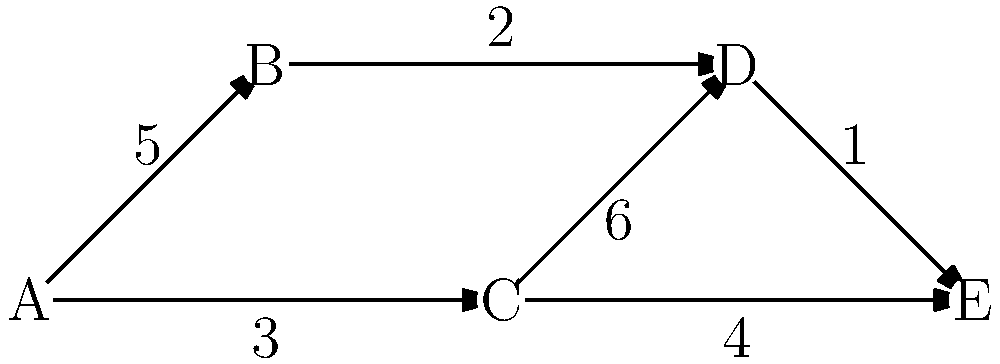In a coding competition, the graph represents the leaderboard progression. Vertices are checkpoints, and edges are challenges with associated point values. Starting from checkpoint A, what is the maximum total points a team can accumulate to reach checkpoint E? To find the maximum total points, we need to determine the path with the highest sum of edge weights from A to E. Let's analyze all possible paths:

1. Path A → B → D → E:
   $5 + 2 + 1 = 8$ points

2. Path A → C → D → E:
   $3 + 6 + 1 = 10$ points

3. Path A → C → E:
   $3 + 4 = 7$ points

To solve this systematically, we can use the concept of dynamic programming:

1. Initialize maximum points for each vertex:
   A: 0, B: 5, C: 3, D: max(5+2, 3+6) = 9, E: max(3+4, 9+1) = 10

2. The maximum points at E is 10, which corresponds to the path A → C → D → E.

Therefore, the maximum total points a team can accumulate from A to E is 10.
Answer: 10 points 